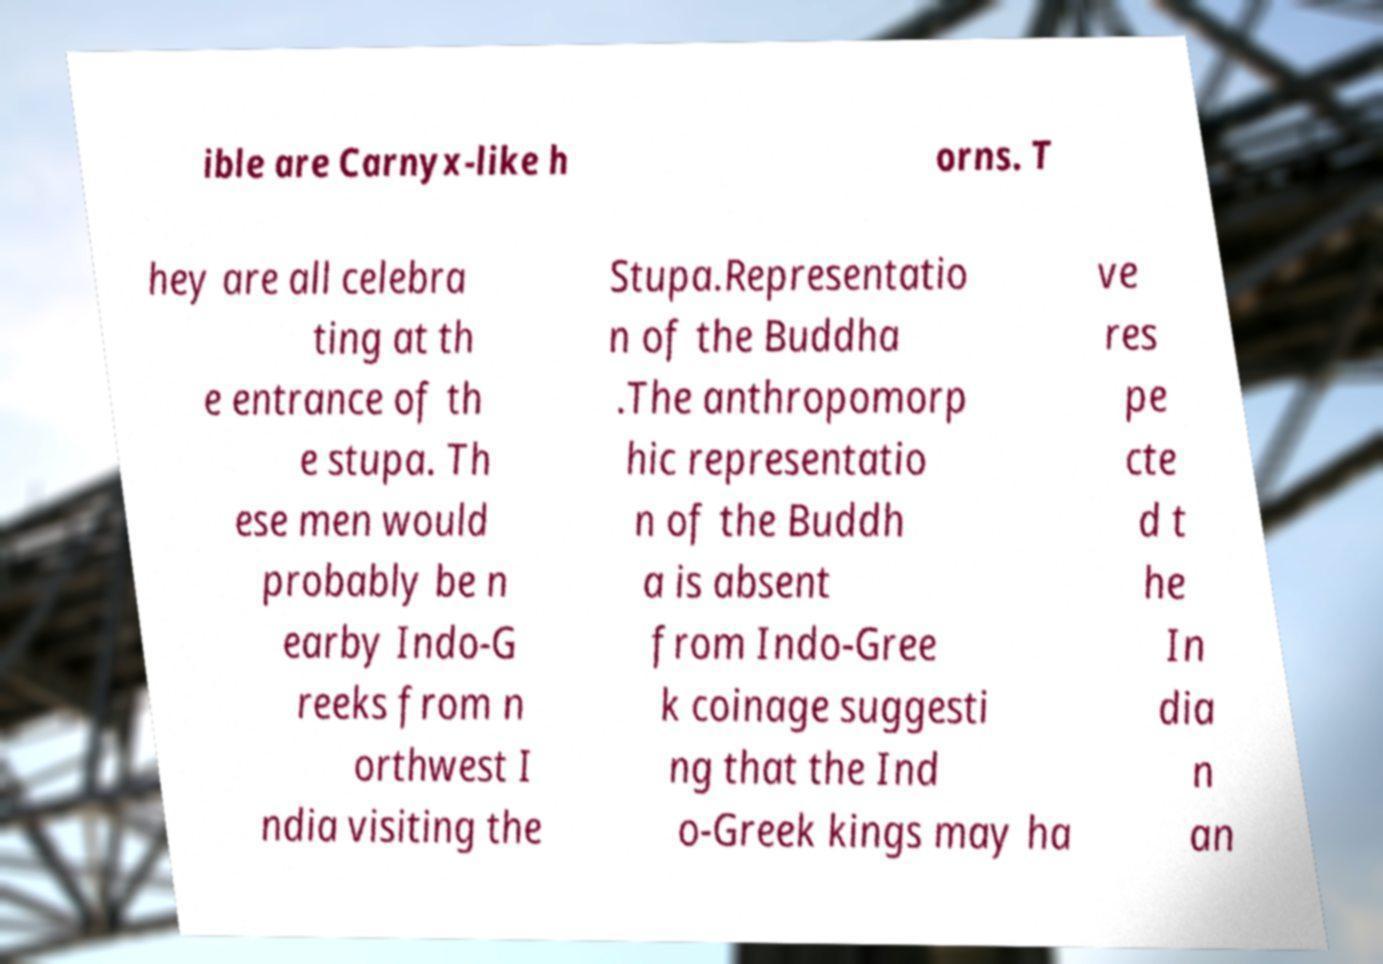Can you accurately transcribe the text from the provided image for me? ible are Carnyx-like h orns. T hey are all celebra ting at th e entrance of th e stupa. Th ese men would probably be n earby Indo-G reeks from n orthwest I ndia visiting the Stupa.Representatio n of the Buddha .The anthropomorp hic representatio n of the Buddh a is absent from Indo-Gree k coinage suggesti ng that the Ind o-Greek kings may ha ve res pe cte d t he In dia n an 